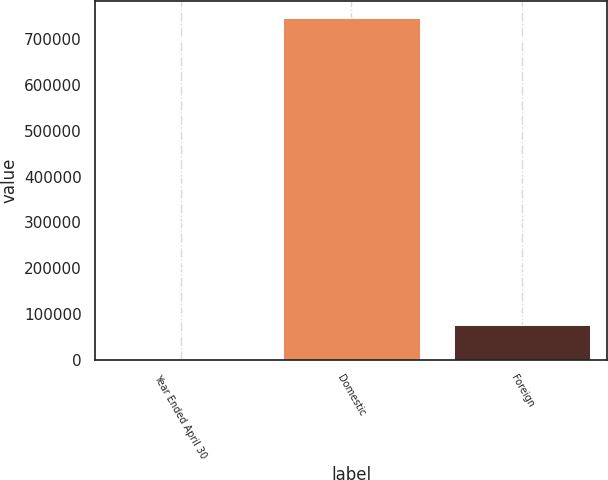<chart> <loc_0><loc_0><loc_500><loc_500><bar_chart><fcel>Year Ended April 30<fcel>Domestic<fcel>Foreign<nl><fcel>2010<fcel>745912<fcel>76400.2<nl></chart> 